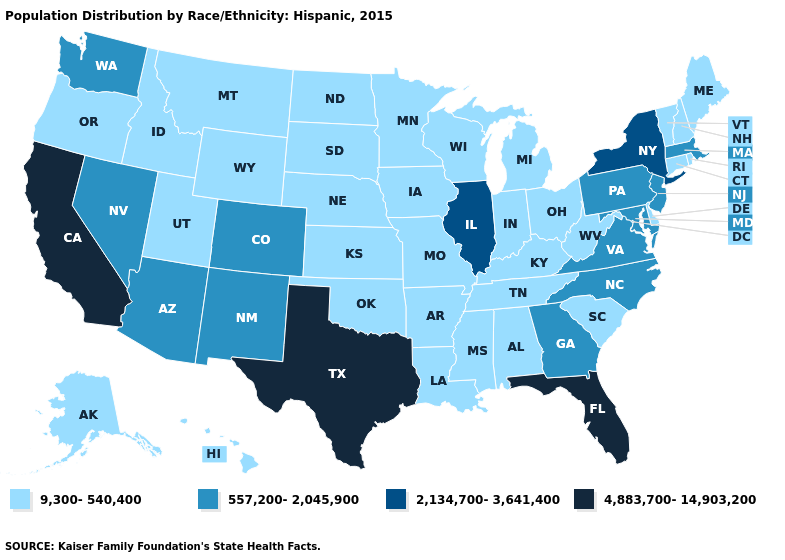What is the value of Iowa?
Give a very brief answer. 9,300-540,400. What is the lowest value in states that border Virginia?
Quick response, please. 9,300-540,400. Name the states that have a value in the range 557,200-2,045,900?
Keep it brief. Arizona, Colorado, Georgia, Maryland, Massachusetts, Nevada, New Jersey, New Mexico, North Carolina, Pennsylvania, Virginia, Washington. What is the lowest value in states that border Georgia?
Keep it brief. 9,300-540,400. What is the value of Michigan?
Keep it brief. 9,300-540,400. Does West Virginia have the lowest value in the USA?
Write a very short answer. Yes. Among the states that border Tennessee , which have the highest value?
Give a very brief answer. Georgia, North Carolina, Virginia. Name the states that have a value in the range 2,134,700-3,641,400?
Concise answer only. Illinois, New York. Among the states that border Arizona , which have the lowest value?
Concise answer only. Utah. What is the lowest value in the USA?
Be succinct. 9,300-540,400. Which states have the highest value in the USA?
Write a very short answer. California, Florida, Texas. Which states have the lowest value in the USA?
Answer briefly. Alabama, Alaska, Arkansas, Connecticut, Delaware, Hawaii, Idaho, Indiana, Iowa, Kansas, Kentucky, Louisiana, Maine, Michigan, Minnesota, Mississippi, Missouri, Montana, Nebraska, New Hampshire, North Dakota, Ohio, Oklahoma, Oregon, Rhode Island, South Carolina, South Dakota, Tennessee, Utah, Vermont, West Virginia, Wisconsin, Wyoming. Which states hav the highest value in the MidWest?
Answer briefly. Illinois. Does Texas have the highest value in the USA?
Be succinct. Yes. 